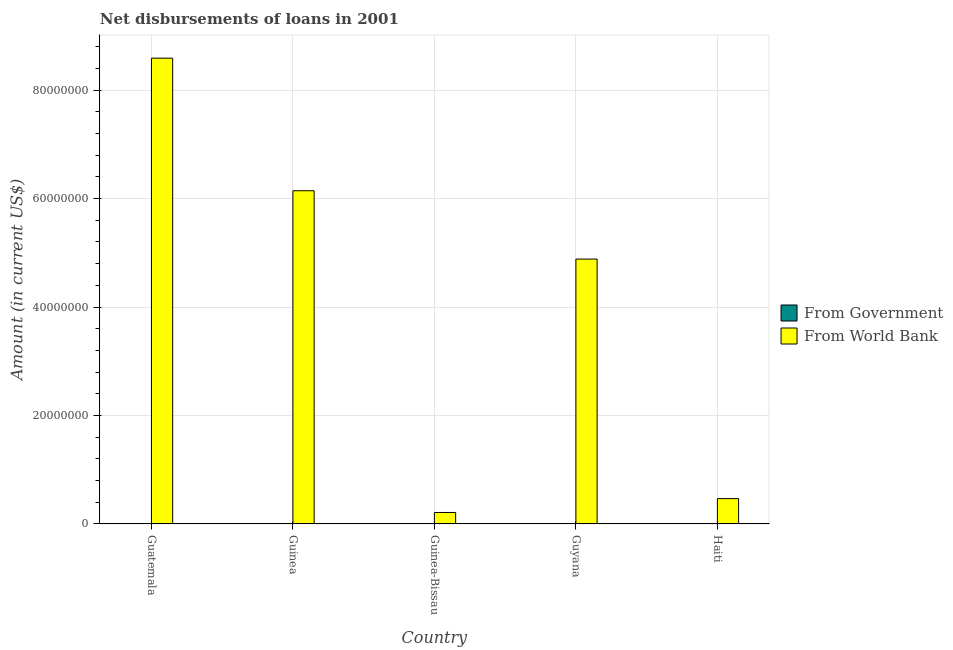Are the number of bars per tick equal to the number of legend labels?
Keep it short and to the point. No. Are the number of bars on each tick of the X-axis equal?
Offer a terse response. Yes. How many bars are there on the 1st tick from the left?
Ensure brevity in your answer.  1. How many bars are there on the 3rd tick from the right?
Your answer should be very brief. 1. What is the label of the 3rd group of bars from the left?
Offer a terse response. Guinea-Bissau. What is the net disbursements of loan from government in Haiti?
Your answer should be very brief. 0. Across all countries, what is the maximum net disbursements of loan from world bank?
Make the answer very short. 8.59e+07. In which country was the net disbursements of loan from world bank maximum?
Ensure brevity in your answer.  Guatemala. What is the total net disbursements of loan from world bank in the graph?
Your response must be concise. 2.03e+08. What is the difference between the net disbursements of loan from world bank in Guyana and that in Haiti?
Your answer should be compact. 4.42e+07. What is the difference between the net disbursements of loan from government in Guinea-Bissau and the net disbursements of loan from world bank in Guatemala?
Ensure brevity in your answer.  -8.59e+07. What is the ratio of the net disbursements of loan from world bank in Guatemala to that in Haiti?
Ensure brevity in your answer.  18.36. What is the difference between the highest and the second highest net disbursements of loan from world bank?
Your response must be concise. 2.44e+07. What is the difference between the highest and the lowest net disbursements of loan from world bank?
Your answer should be compact. 8.38e+07. In how many countries, is the net disbursements of loan from government greater than the average net disbursements of loan from government taken over all countries?
Provide a short and direct response. 0. Is the sum of the net disbursements of loan from world bank in Guinea and Guyana greater than the maximum net disbursements of loan from government across all countries?
Give a very brief answer. Yes. How many bars are there?
Ensure brevity in your answer.  5. How many countries are there in the graph?
Your response must be concise. 5. What is the difference between two consecutive major ticks on the Y-axis?
Give a very brief answer. 2.00e+07. How are the legend labels stacked?
Your response must be concise. Vertical. What is the title of the graph?
Your response must be concise. Net disbursements of loans in 2001. Does "Merchandise exports" appear as one of the legend labels in the graph?
Make the answer very short. No. What is the Amount (in current US$) in From Government in Guatemala?
Make the answer very short. 0. What is the Amount (in current US$) in From World Bank in Guatemala?
Make the answer very short. 8.59e+07. What is the Amount (in current US$) in From Government in Guinea?
Offer a terse response. 0. What is the Amount (in current US$) in From World Bank in Guinea?
Your answer should be compact. 6.14e+07. What is the Amount (in current US$) of From World Bank in Guinea-Bissau?
Keep it short and to the point. 2.12e+06. What is the Amount (in current US$) of From Government in Guyana?
Give a very brief answer. 0. What is the Amount (in current US$) in From World Bank in Guyana?
Give a very brief answer. 4.88e+07. What is the Amount (in current US$) of From Government in Haiti?
Offer a terse response. 0. What is the Amount (in current US$) of From World Bank in Haiti?
Offer a terse response. 4.68e+06. Across all countries, what is the maximum Amount (in current US$) in From World Bank?
Offer a very short reply. 8.59e+07. Across all countries, what is the minimum Amount (in current US$) in From World Bank?
Keep it short and to the point. 2.12e+06. What is the total Amount (in current US$) of From Government in the graph?
Your response must be concise. 0. What is the total Amount (in current US$) of From World Bank in the graph?
Ensure brevity in your answer.  2.03e+08. What is the difference between the Amount (in current US$) in From World Bank in Guatemala and that in Guinea?
Your answer should be very brief. 2.44e+07. What is the difference between the Amount (in current US$) of From World Bank in Guatemala and that in Guinea-Bissau?
Your answer should be very brief. 8.38e+07. What is the difference between the Amount (in current US$) in From World Bank in Guatemala and that in Guyana?
Offer a terse response. 3.70e+07. What is the difference between the Amount (in current US$) in From World Bank in Guatemala and that in Haiti?
Offer a very short reply. 8.12e+07. What is the difference between the Amount (in current US$) in From World Bank in Guinea and that in Guinea-Bissau?
Your response must be concise. 5.93e+07. What is the difference between the Amount (in current US$) in From World Bank in Guinea and that in Guyana?
Ensure brevity in your answer.  1.26e+07. What is the difference between the Amount (in current US$) of From World Bank in Guinea and that in Haiti?
Provide a succinct answer. 5.68e+07. What is the difference between the Amount (in current US$) of From World Bank in Guinea-Bissau and that in Guyana?
Your response must be concise. -4.67e+07. What is the difference between the Amount (in current US$) in From World Bank in Guinea-Bissau and that in Haiti?
Offer a very short reply. -2.56e+06. What is the difference between the Amount (in current US$) in From World Bank in Guyana and that in Haiti?
Make the answer very short. 4.42e+07. What is the average Amount (in current US$) of From World Bank per country?
Offer a terse response. 4.06e+07. What is the ratio of the Amount (in current US$) of From World Bank in Guatemala to that in Guinea?
Offer a very short reply. 1.4. What is the ratio of the Amount (in current US$) of From World Bank in Guatemala to that in Guinea-Bissau?
Offer a terse response. 40.47. What is the ratio of the Amount (in current US$) of From World Bank in Guatemala to that in Guyana?
Give a very brief answer. 1.76. What is the ratio of the Amount (in current US$) in From World Bank in Guatemala to that in Haiti?
Your answer should be compact. 18.36. What is the ratio of the Amount (in current US$) of From World Bank in Guinea to that in Guinea-Bissau?
Give a very brief answer. 28.95. What is the ratio of the Amount (in current US$) of From World Bank in Guinea to that in Guyana?
Your answer should be compact. 1.26. What is the ratio of the Amount (in current US$) in From World Bank in Guinea to that in Haiti?
Give a very brief answer. 13.13. What is the ratio of the Amount (in current US$) of From World Bank in Guinea-Bissau to that in Guyana?
Provide a succinct answer. 0.04. What is the ratio of the Amount (in current US$) of From World Bank in Guinea-Bissau to that in Haiti?
Your answer should be very brief. 0.45. What is the ratio of the Amount (in current US$) of From World Bank in Guyana to that in Haiti?
Keep it short and to the point. 10.44. What is the difference between the highest and the second highest Amount (in current US$) in From World Bank?
Offer a very short reply. 2.44e+07. What is the difference between the highest and the lowest Amount (in current US$) in From World Bank?
Your answer should be compact. 8.38e+07. 